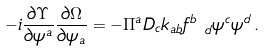<formula> <loc_0><loc_0><loc_500><loc_500>- i \frac { \partial \Upsilon } { \partial \psi ^ { a } } \frac { \partial \Omega } { \partial \psi _ { a } } = - \Pi ^ { a } D _ { c } k _ { a b } f ^ { b } _ { \ d } \psi ^ { c } \psi ^ { d } \, .</formula> 